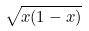Convert formula to latex. <formula><loc_0><loc_0><loc_500><loc_500>\sqrt { x ( 1 - x ) }</formula> 